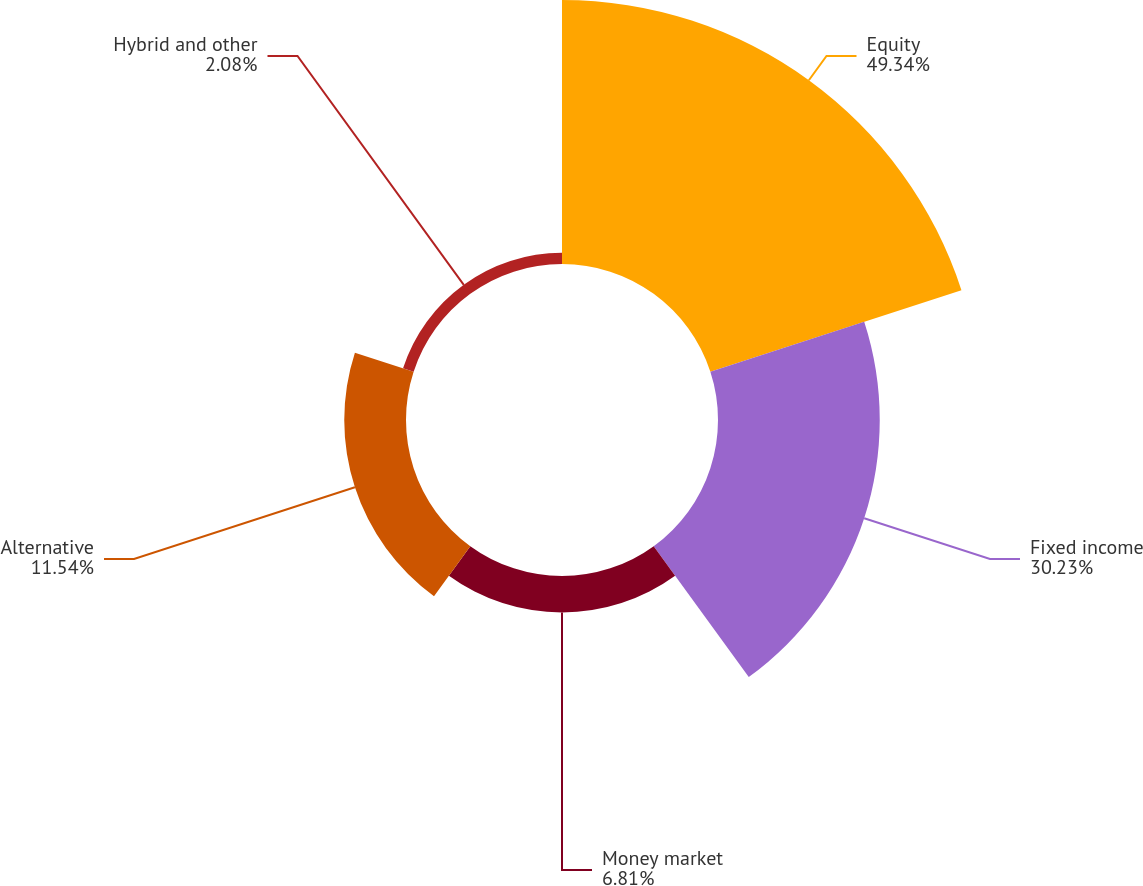<chart> <loc_0><loc_0><loc_500><loc_500><pie_chart><fcel>Equity<fcel>Fixed income<fcel>Money market<fcel>Alternative<fcel>Hybrid and other<nl><fcel>49.34%<fcel>30.23%<fcel>6.81%<fcel>11.54%<fcel>2.08%<nl></chart> 